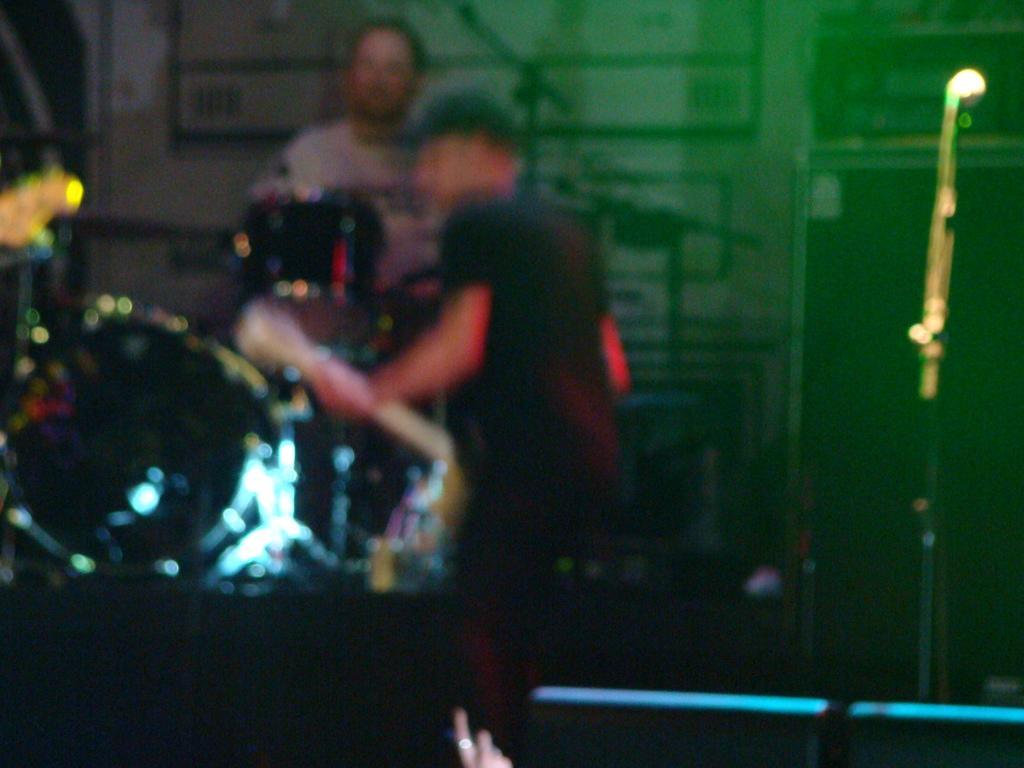Could you give a brief overview of what you see in this image? This picture seems to be clicked inside. On the left we can see the two persons and there are some items. On the right there is a metal rod. The background of the image is blurry and we can see the lights. 